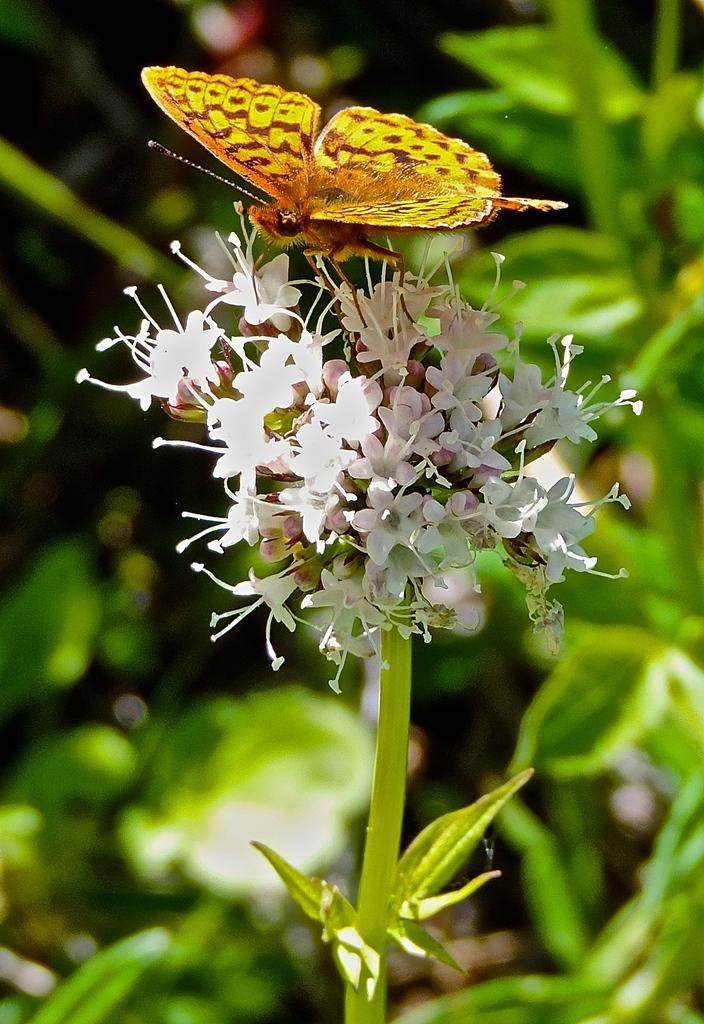What is the main subject of the image? There is a butterfly in the image. Where is the butterfly located? The butterfly is on a flower plant. What can be seen in the background of the image? There are many leaves in the background of the image. What type of trucks can be seen in the image? There are no trucks present in the image; it features a butterfly on a flower plant. How is the butterfly related to the person's brother in the image? There is no mention of a brother or any person in the image; it only features a butterfly on a flower plant. 